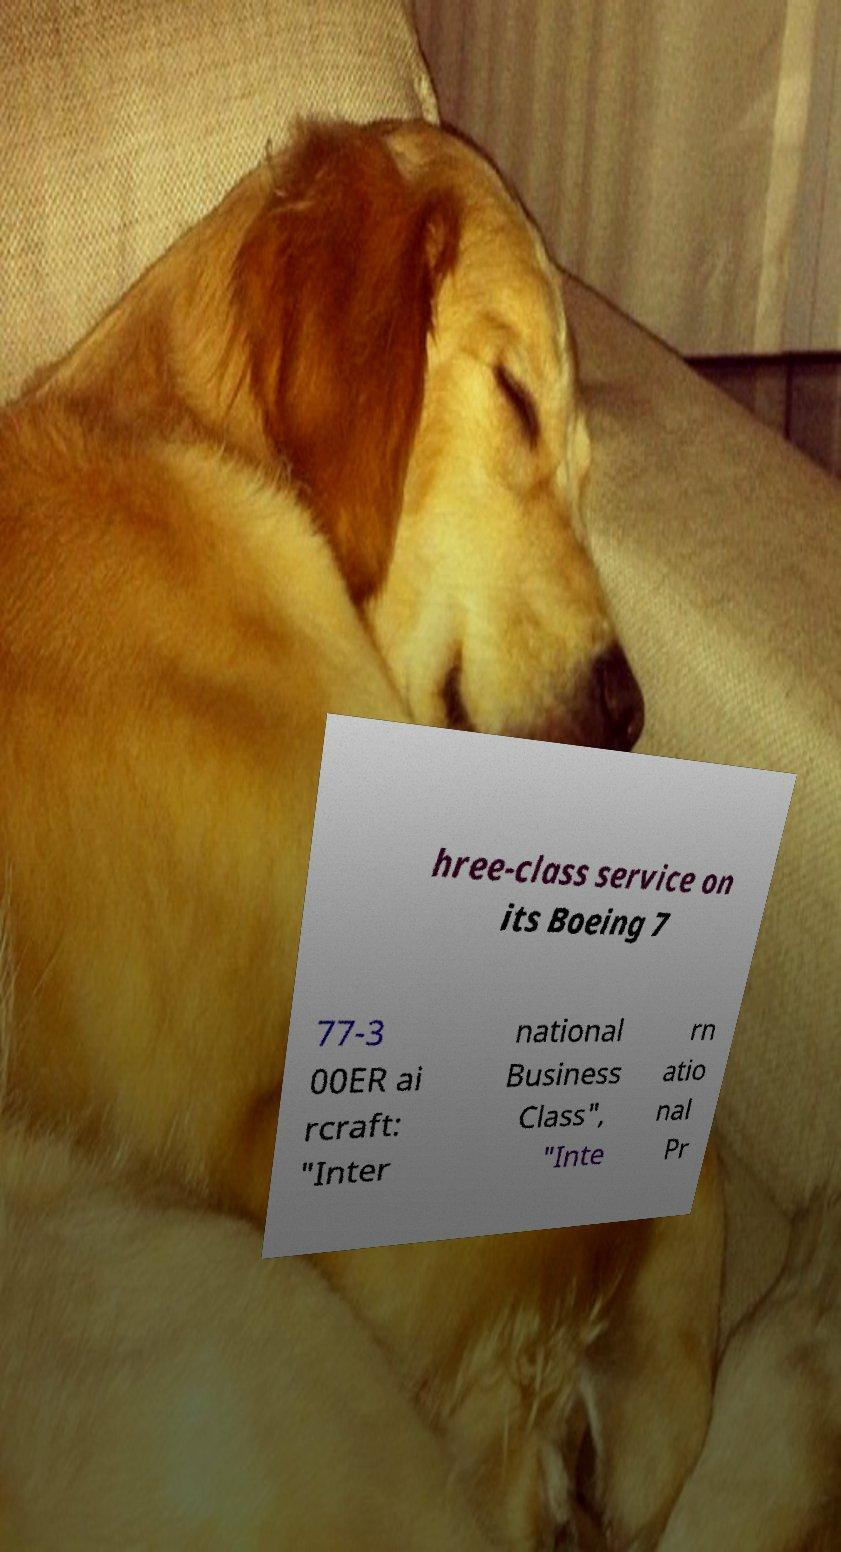Can you read and provide the text displayed in the image?This photo seems to have some interesting text. Can you extract and type it out for me? hree-class service on its Boeing 7 77-3 00ER ai rcraft: "Inter national Business Class", "Inte rn atio nal Pr 